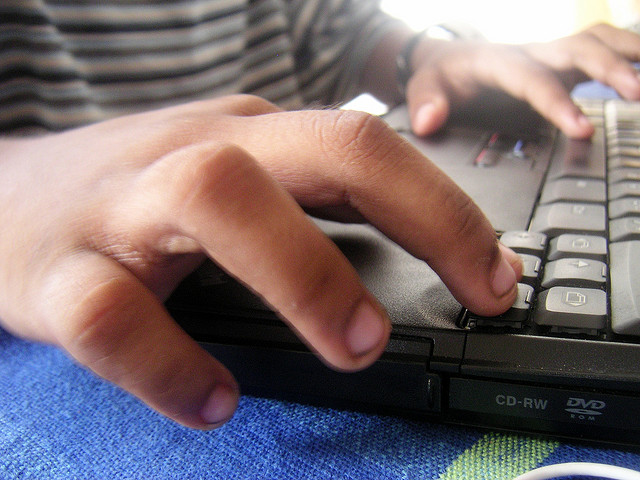<image>Is he playing a game or doing school work? I don't know if he is playing a game or doing school work. Is he playing a game or doing school work? I am not sure if he is playing a game or doing school work. It can be seen that he is playing a game. 